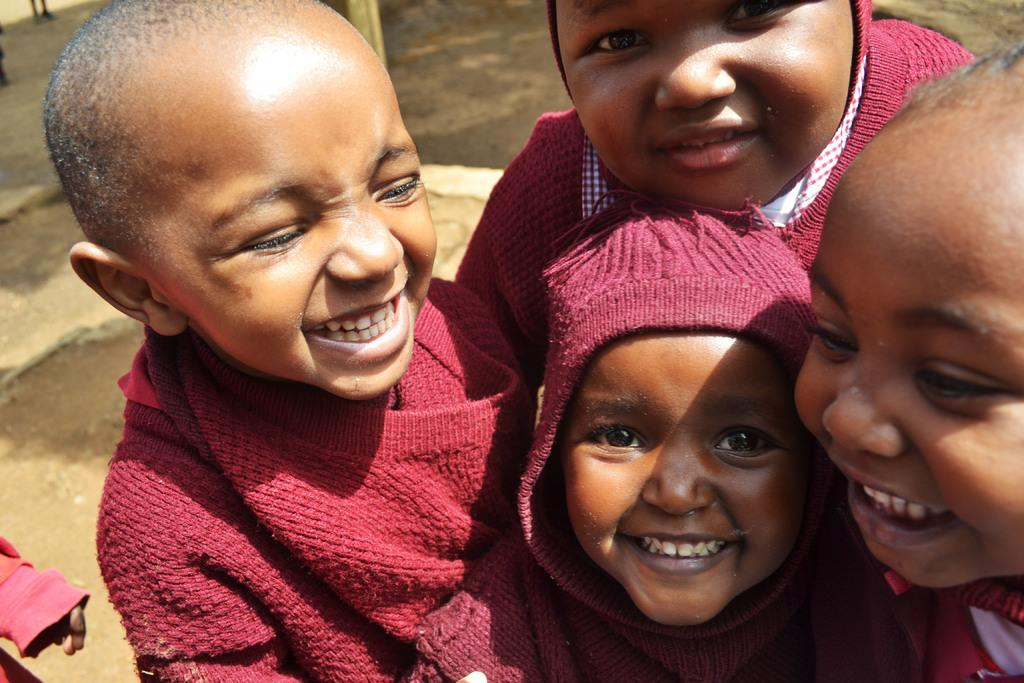What is the main subject of the image? The main subject of the image is kids standing. What is the emotional state of the kids in the image? The kids are smiling in the image. What type of surface is visible beneath the kids in the image? There is ground visible in the image. What type of hen can be seen playing music in the image? There is no hen or music present in the image. What type of company is associated with the kids in the image? There is no reference to any company in the image; it simply features kids standing and smiling. 